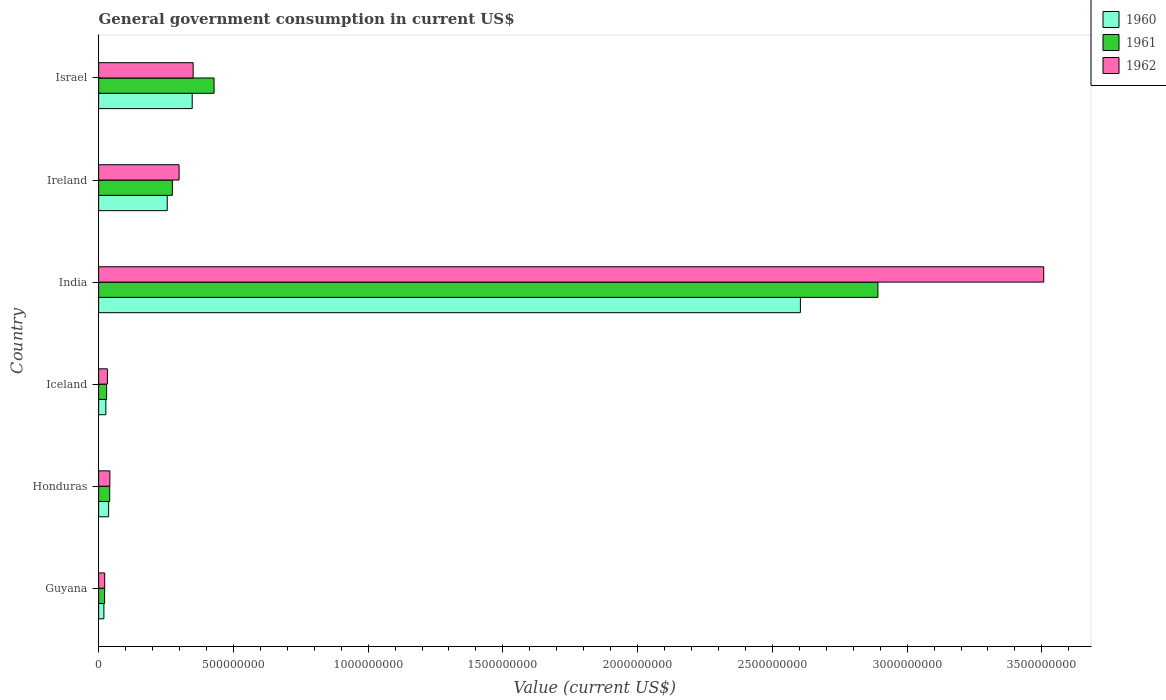How many groups of bars are there?
Offer a very short reply. 6. How many bars are there on the 6th tick from the bottom?
Make the answer very short. 3. What is the label of the 2nd group of bars from the top?
Keep it short and to the point. Ireland. What is the government conusmption in 1960 in Iceland?
Give a very brief answer. 2.68e+07. Across all countries, what is the maximum government conusmption in 1961?
Offer a very short reply. 2.89e+09. Across all countries, what is the minimum government conusmption in 1960?
Keep it short and to the point. 1.95e+07. In which country was the government conusmption in 1960 minimum?
Provide a succinct answer. Guyana. What is the total government conusmption in 1960 in the graph?
Give a very brief answer. 3.29e+09. What is the difference between the government conusmption in 1960 in Ireland and that in Israel?
Give a very brief answer. -9.27e+07. What is the difference between the government conusmption in 1960 in India and the government conusmption in 1962 in Ireland?
Make the answer very short. 2.31e+09. What is the average government conusmption in 1962 per country?
Offer a terse response. 7.09e+08. What is the difference between the government conusmption in 1960 and government conusmption in 1962 in Honduras?
Offer a very short reply. -4.50e+06. What is the ratio of the government conusmption in 1960 in Iceland to that in India?
Ensure brevity in your answer.  0.01. Is the difference between the government conusmption in 1960 in Honduras and Iceland greater than the difference between the government conusmption in 1962 in Honduras and Iceland?
Offer a very short reply. Yes. What is the difference between the highest and the second highest government conusmption in 1961?
Give a very brief answer. 2.46e+09. What is the difference between the highest and the lowest government conusmption in 1960?
Ensure brevity in your answer.  2.58e+09. What does the 2nd bar from the top in Iceland represents?
Offer a terse response. 1961. What does the 2nd bar from the bottom in Iceland represents?
Your answer should be very brief. 1961. Is it the case that in every country, the sum of the government conusmption in 1962 and government conusmption in 1961 is greater than the government conusmption in 1960?
Your answer should be very brief. Yes. Are all the bars in the graph horizontal?
Ensure brevity in your answer.  Yes. How many countries are there in the graph?
Your answer should be compact. 6. What is the difference between two consecutive major ticks on the X-axis?
Your answer should be compact. 5.00e+08. Are the values on the major ticks of X-axis written in scientific E-notation?
Offer a very short reply. No. Does the graph contain any zero values?
Give a very brief answer. No. Does the graph contain grids?
Make the answer very short. No. Where does the legend appear in the graph?
Offer a very short reply. Top right. How are the legend labels stacked?
Your answer should be compact. Vertical. What is the title of the graph?
Provide a short and direct response. General government consumption in current US$. What is the label or title of the X-axis?
Keep it short and to the point. Value (current US$). What is the label or title of the Y-axis?
Offer a terse response. Country. What is the Value (current US$) in 1960 in Guyana?
Your answer should be compact. 1.95e+07. What is the Value (current US$) in 1961 in Guyana?
Make the answer very short. 2.22e+07. What is the Value (current US$) of 1962 in Guyana?
Offer a very short reply. 2.25e+07. What is the Value (current US$) in 1960 in Honduras?
Your response must be concise. 3.72e+07. What is the Value (current US$) of 1961 in Honduras?
Your answer should be very brief. 4.10e+07. What is the Value (current US$) of 1962 in Honduras?
Provide a short and direct response. 4.16e+07. What is the Value (current US$) of 1960 in Iceland?
Your answer should be very brief. 2.68e+07. What is the Value (current US$) of 1961 in Iceland?
Your answer should be very brief. 2.95e+07. What is the Value (current US$) in 1962 in Iceland?
Give a very brief answer. 3.25e+07. What is the Value (current US$) in 1960 in India?
Your answer should be compact. 2.60e+09. What is the Value (current US$) in 1961 in India?
Provide a succinct answer. 2.89e+09. What is the Value (current US$) of 1962 in India?
Provide a short and direct response. 3.51e+09. What is the Value (current US$) in 1960 in Ireland?
Ensure brevity in your answer.  2.55e+08. What is the Value (current US$) in 1961 in Ireland?
Your response must be concise. 2.74e+08. What is the Value (current US$) of 1962 in Ireland?
Make the answer very short. 2.99e+08. What is the Value (current US$) in 1960 in Israel?
Your answer should be compact. 3.47e+08. What is the Value (current US$) of 1961 in Israel?
Ensure brevity in your answer.  4.28e+08. What is the Value (current US$) of 1962 in Israel?
Your response must be concise. 3.51e+08. Across all countries, what is the maximum Value (current US$) of 1960?
Your response must be concise. 2.60e+09. Across all countries, what is the maximum Value (current US$) in 1961?
Ensure brevity in your answer.  2.89e+09. Across all countries, what is the maximum Value (current US$) in 1962?
Your answer should be very brief. 3.51e+09. Across all countries, what is the minimum Value (current US$) in 1960?
Provide a short and direct response. 1.95e+07. Across all countries, what is the minimum Value (current US$) of 1961?
Ensure brevity in your answer.  2.22e+07. Across all countries, what is the minimum Value (current US$) in 1962?
Provide a short and direct response. 2.25e+07. What is the total Value (current US$) in 1960 in the graph?
Ensure brevity in your answer.  3.29e+09. What is the total Value (current US$) in 1961 in the graph?
Provide a succinct answer. 3.69e+09. What is the total Value (current US$) in 1962 in the graph?
Offer a very short reply. 4.25e+09. What is the difference between the Value (current US$) in 1960 in Guyana and that in Honduras?
Ensure brevity in your answer.  -1.77e+07. What is the difference between the Value (current US$) in 1961 in Guyana and that in Honduras?
Make the answer very short. -1.89e+07. What is the difference between the Value (current US$) of 1962 in Guyana and that in Honduras?
Your response must be concise. -1.91e+07. What is the difference between the Value (current US$) of 1960 in Guyana and that in Iceland?
Ensure brevity in your answer.  -7.28e+06. What is the difference between the Value (current US$) of 1961 in Guyana and that in Iceland?
Give a very brief answer. -7.36e+06. What is the difference between the Value (current US$) in 1962 in Guyana and that in Iceland?
Your answer should be very brief. -1.00e+07. What is the difference between the Value (current US$) of 1960 in Guyana and that in India?
Your response must be concise. -2.58e+09. What is the difference between the Value (current US$) in 1961 in Guyana and that in India?
Your response must be concise. -2.87e+09. What is the difference between the Value (current US$) of 1962 in Guyana and that in India?
Keep it short and to the point. -3.48e+09. What is the difference between the Value (current US$) of 1960 in Guyana and that in Ireland?
Give a very brief answer. -2.35e+08. What is the difference between the Value (current US$) in 1961 in Guyana and that in Ireland?
Offer a terse response. -2.51e+08. What is the difference between the Value (current US$) of 1962 in Guyana and that in Ireland?
Your response must be concise. -2.76e+08. What is the difference between the Value (current US$) in 1960 in Guyana and that in Israel?
Ensure brevity in your answer.  -3.28e+08. What is the difference between the Value (current US$) of 1961 in Guyana and that in Israel?
Keep it short and to the point. -4.06e+08. What is the difference between the Value (current US$) in 1962 in Guyana and that in Israel?
Make the answer very short. -3.28e+08. What is the difference between the Value (current US$) in 1960 in Honduras and that in Iceland?
Make the answer very short. 1.04e+07. What is the difference between the Value (current US$) of 1961 in Honduras and that in Iceland?
Ensure brevity in your answer.  1.15e+07. What is the difference between the Value (current US$) of 1962 in Honduras and that in Iceland?
Provide a succinct answer. 9.12e+06. What is the difference between the Value (current US$) in 1960 in Honduras and that in India?
Give a very brief answer. -2.57e+09. What is the difference between the Value (current US$) in 1961 in Honduras and that in India?
Offer a very short reply. -2.85e+09. What is the difference between the Value (current US$) of 1962 in Honduras and that in India?
Give a very brief answer. -3.47e+09. What is the difference between the Value (current US$) of 1960 in Honduras and that in Ireland?
Give a very brief answer. -2.17e+08. What is the difference between the Value (current US$) of 1961 in Honduras and that in Ireland?
Offer a very short reply. -2.33e+08. What is the difference between the Value (current US$) in 1962 in Honduras and that in Ireland?
Your response must be concise. -2.57e+08. What is the difference between the Value (current US$) of 1960 in Honduras and that in Israel?
Provide a short and direct response. -3.10e+08. What is the difference between the Value (current US$) of 1961 in Honduras and that in Israel?
Provide a short and direct response. -3.87e+08. What is the difference between the Value (current US$) of 1962 in Honduras and that in Israel?
Ensure brevity in your answer.  -3.09e+08. What is the difference between the Value (current US$) of 1960 in Iceland and that in India?
Your answer should be compact. -2.58e+09. What is the difference between the Value (current US$) in 1961 in Iceland and that in India?
Provide a short and direct response. -2.86e+09. What is the difference between the Value (current US$) in 1962 in Iceland and that in India?
Ensure brevity in your answer.  -3.47e+09. What is the difference between the Value (current US$) in 1960 in Iceland and that in Ireland?
Provide a succinct answer. -2.28e+08. What is the difference between the Value (current US$) of 1961 in Iceland and that in Ireland?
Offer a very short reply. -2.44e+08. What is the difference between the Value (current US$) of 1962 in Iceland and that in Ireland?
Ensure brevity in your answer.  -2.66e+08. What is the difference between the Value (current US$) of 1960 in Iceland and that in Israel?
Provide a short and direct response. -3.20e+08. What is the difference between the Value (current US$) in 1961 in Iceland and that in Israel?
Offer a very short reply. -3.99e+08. What is the difference between the Value (current US$) of 1962 in Iceland and that in Israel?
Your answer should be compact. -3.18e+08. What is the difference between the Value (current US$) in 1960 in India and that in Ireland?
Give a very brief answer. 2.35e+09. What is the difference between the Value (current US$) in 1961 in India and that in Ireland?
Ensure brevity in your answer.  2.62e+09. What is the difference between the Value (current US$) in 1962 in India and that in Ireland?
Your response must be concise. 3.21e+09. What is the difference between the Value (current US$) of 1960 in India and that in Israel?
Provide a short and direct response. 2.26e+09. What is the difference between the Value (current US$) in 1961 in India and that in Israel?
Provide a short and direct response. 2.46e+09. What is the difference between the Value (current US$) of 1962 in India and that in Israel?
Provide a succinct answer. 3.16e+09. What is the difference between the Value (current US$) in 1960 in Ireland and that in Israel?
Your answer should be very brief. -9.27e+07. What is the difference between the Value (current US$) in 1961 in Ireland and that in Israel?
Offer a terse response. -1.55e+08. What is the difference between the Value (current US$) of 1962 in Ireland and that in Israel?
Make the answer very short. -5.21e+07. What is the difference between the Value (current US$) in 1960 in Guyana and the Value (current US$) in 1961 in Honduras?
Provide a short and direct response. -2.16e+07. What is the difference between the Value (current US$) in 1960 in Guyana and the Value (current US$) in 1962 in Honduras?
Give a very brief answer. -2.22e+07. What is the difference between the Value (current US$) of 1961 in Guyana and the Value (current US$) of 1962 in Honduras?
Keep it short and to the point. -1.95e+07. What is the difference between the Value (current US$) of 1960 in Guyana and the Value (current US$) of 1961 in Iceland?
Provide a short and direct response. -1.00e+07. What is the difference between the Value (current US$) in 1960 in Guyana and the Value (current US$) in 1962 in Iceland?
Provide a succinct answer. -1.30e+07. What is the difference between the Value (current US$) of 1961 in Guyana and the Value (current US$) of 1962 in Iceland?
Your answer should be very brief. -1.04e+07. What is the difference between the Value (current US$) in 1960 in Guyana and the Value (current US$) in 1961 in India?
Ensure brevity in your answer.  -2.87e+09. What is the difference between the Value (current US$) in 1960 in Guyana and the Value (current US$) in 1962 in India?
Ensure brevity in your answer.  -3.49e+09. What is the difference between the Value (current US$) in 1961 in Guyana and the Value (current US$) in 1962 in India?
Your answer should be very brief. -3.48e+09. What is the difference between the Value (current US$) of 1960 in Guyana and the Value (current US$) of 1961 in Ireland?
Provide a short and direct response. -2.54e+08. What is the difference between the Value (current US$) in 1960 in Guyana and the Value (current US$) in 1962 in Ireland?
Ensure brevity in your answer.  -2.79e+08. What is the difference between the Value (current US$) of 1961 in Guyana and the Value (current US$) of 1962 in Ireland?
Offer a very short reply. -2.76e+08. What is the difference between the Value (current US$) of 1960 in Guyana and the Value (current US$) of 1961 in Israel?
Your response must be concise. -4.09e+08. What is the difference between the Value (current US$) of 1960 in Guyana and the Value (current US$) of 1962 in Israel?
Your answer should be compact. -3.31e+08. What is the difference between the Value (current US$) of 1961 in Guyana and the Value (current US$) of 1962 in Israel?
Ensure brevity in your answer.  -3.29e+08. What is the difference between the Value (current US$) of 1960 in Honduras and the Value (current US$) of 1961 in Iceland?
Your answer should be compact. 7.62e+06. What is the difference between the Value (current US$) in 1960 in Honduras and the Value (current US$) in 1962 in Iceland?
Make the answer very short. 4.62e+06. What is the difference between the Value (current US$) in 1961 in Honduras and the Value (current US$) in 1962 in Iceland?
Your response must be concise. 8.52e+06. What is the difference between the Value (current US$) in 1960 in Honduras and the Value (current US$) in 1961 in India?
Keep it short and to the point. -2.85e+09. What is the difference between the Value (current US$) of 1960 in Honduras and the Value (current US$) of 1962 in India?
Keep it short and to the point. -3.47e+09. What is the difference between the Value (current US$) of 1961 in Honduras and the Value (current US$) of 1962 in India?
Ensure brevity in your answer.  -3.47e+09. What is the difference between the Value (current US$) in 1960 in Honduras and the Value (current US$) in 1961 in Ireland?
Give a very brief answer. -2.37e+08. What is the difference between the Value (current US$) in 1960 in Honduras and the Value (current US$) in 1962 in Ireland?
Your answer should be compact. -2.61e+08. What is the difference between the Value (current US$) in 1961 in Honduras and the Value (current US$) in 1962 in Ireland?
Your answer should be compact. -2.58e+08. What is the difference between the Value (current US$) of 1960 in Honduras and the Value (current US$) of 1961 in Israel?
Make the answer very short. -3.91e+08. What is the difference between the Value (current US$) in 1960 in Honduras and the Value (current US$) in 1962 in Israel?
Your answer should be compact. -3.14e+08. What is the difference between the Value (current US$) in 1961 in Honduras and the Value (current US$) in 1962 in Israel?
Give a very brief answer. -3.10e+08. What is the difference between the Value (current US$) in 1960 in Iceland and the Value (current US$) in 1961 in India?
Your answer should be compact. -2.86e+09. What is the difference between the Value (current US$) in 1960 in Iceland and the Value (current US$) in 1962 in India?
Provide a short and direct response. -3.48e+09. What is the difference between the Value (current US$) of 1961 in Iceland and the Value (current US$) of 1962 in India?
Your response must be concise. -3.48e+09. What is the difference between the Value (current US$) of 1960 in Iceland and the Value (current US$) of 1961 in Ireland?
Provide a succinct answer. -2.47e+08. What is the difference between the Value (current US$) in 1960 in Iceland and the Value (current US$) in 1962 in Ireland?
Provide a short and direct response. -2.72e+08. What is the difference between the Value (current US$) of 1961 in Iceland and the Value (current US$) of 1962 in Ireland?
Offer a very short reply. -2.69e+08. What is the difference between the Value (current US$) in 1960 in Iceland and the Value (current US$) in 1961 in Israel?
Make the answer very short. -4.02e+08. What is the difference between the Value (current US$) of 1960 in Iceland and the Value (current US$) of 1962 in Israel?
Offer a terse response. -3.24e+08. What is the difference between the Value (current US$) of 1961 in Iceland and the Value (current US$) of 1962 in Israel?
Give a very brief answer. -3.21e+08. What is the difference between the Value (current US$) in 1960 in India and the Value (current US$) in 1961 in Ireland?
Ensure brevity in your answer.  2.33e+09. What is the difference between the Value (current US$) of 1960 in India and the Value (current US$) of 1962 in Ireland?
Ensure brevity in your answer.  2.31e+09. What is the difference between the Value (current US$) in 1961 in India and the Value (current US$) in 1962 in Ireland?
Your response must be concise. 2.59e+09. What is the difference between the Value (current US$) of 1960 in India and the Value (current US$) of 1961 in Israel?
Ensure brevity in your answer.  2.18e+09. What is the difference between the Value (current US$) of 1960 in India and the Value (current US$) of 1962 in Israel?
Make the answer very short. 2.25e+09. What is the difference between the Value (current US$) of 1961 in India and the Value (current US$) of 1962 in Israel?
Provide a short and direct response. 2.54e+09. What is the difference between the Value (current US$) of 1960 in Ireland and the Value (current US$) of 1961 in Israel?
Your answer should be very brief. -1.74e+08. What is the difference between the Value (current US$) of 1960 in Ireland and the Value (current US$) of 1962 in Israel?
Your response must be concise. -9.61e+07. What is the difference between the Value (current US$) of 1961 in Ireland and the Value (current US$) of 1962 in Israel?
Ensure brevity in your answer.  -7.70e+07. What is the average Value (current US$) in 1960 per country?
Your answer should be very brief. 5.48e+08. What is the average Value (current US$) of 1961 per country?
Provide a short and direct response. 6.14e+08. What is the average Value (current US$) in 1962 per country?
Keep it short and to the point. 7.09e+08. What is the difference between the Value (current US$) of 1960 and Value (current US$) of 1961 in Guyana?
Offer a very short reply. -2.68e+06. What is the difference between the Value (current US$) in 1960 and Value (current US$) in 1962 in Guyana?
Ensure brevity in your answer.  -3.03e+06. What is the difference between the Value (current US$) in 1961 and Value (current US$) in 1962 in Guyana?
Give a very brief answer. -3.50e+05. What is the difference between the Value (current US$) in 1960 and Value (current US$) in 1961 in Honduras?
Offer a very short reply. -3.90e+06. What is the difference between the Value (current US$) of 1960 and Value (current US$) of 1962 in Honduras?
Ensure brevity in your answer.  -4.50e+06. What is the difference between the Value (current US$) in 1961 and Value (current US$) in 1962 in Honduras?
Ensure brevity in your answer.  -6.00e+05. What is the difference between the Value (current US$) in 1960 and Value (current US$) in 1961 in Iceland?
Give a very brief answer. -2.77e+06. What is the difference between the Value (current US$) of 1960 and Value (current US$) of 1962 in Iceland?
Ensure brevity in your answer.  -5.77e+06. What is the difference between the Value (current US$) in 1961 and Value (current US$) in 1962 in Iceland?
Offer a terse response. -3.00e+06. What is the difference between the Value (current US$) in 1960 and Value (current US$) in 1961 in India?
Provide a short and direct response. -2.88e+08. What is the difference between the Value (current US$) of 1960 and Value (current US$) of 1962 in India?
Offer a terse response. -9.03e+08. What is the difference between the Value (current US$) in 1961 and Value (current US$) in 1962 in India?
Give a very brief answer. -6.15e+08. What is the difference between the Value (current US$) in 1960 and Value (current US$) in 1961 in Ireland?
Give a very brief answer. -1.91e+07. What is the difference between the Value (current US$) in 1960 and Value (current US$) in 1962 in Ireland?
Provide a succinct answer. -4.40e+07. What is the difference between the Value (current US$) in 1961 and Value (current US$) in 1962 in Ireland?
Offer a very short reply. -2.49e+07. What is the difference between the Value (current US$) of 1960 and Value (current US$) of 1961 in Israel?
Provide a short and direct response. -8.11e+07. What is the difference between the Value (current US$) in 1960 and Value (current US$) in 1962 in Israel?
Your response must be concise. -3.47e+06. What is the difference between the Value (current US$) of 1961 and Value (current US$) of 1962 in Israel?
Ensure brevity in your answer.  7.76e+07. What is the ratio of the Value (current US$) of 1960 in Guyana to that in Honduras?
Make the answer very short. 0.52. What is the ratio of the Value (current US$) of 1961 in Guyana to that in Honduras?
Offer a very short reply. 0.54. What is the ratio of the Value (current US$) of 1962 in Guyana to that in Honduras?
Provide a succinct answer. 0.54. What is the ratio of the Value (current US$) in 1960 in Guyana to that in Iceland?
Your response must be concise. 0.73. What is the ratio of the Value (current US$) in 1961 in Guyana to that in Iceland?
Your answer should be very brief. 0.75. What is the ratio of the Value (current US$) of 1962 in Guyana to that in Iceland?
Give a very brief answer. 0.69. What is the ratio of the Value (current US$) of 1960 in Guyana to that in India?
Offer a terse response. 0.01. What is the ratio of the Value (current US$) of 1961 in Guyana to that in India?
Provide a short and direct response. 0.01. What is the ratio of the Value (current US$) of 1962 in Guyana to that in India?
Your answer should be very brief. 0.01. What is the ratio of the Value (current US$) in 1960 in Guyana to that in Ireland?
Your response must be concise. 0.08. What is the ratio of the Value (current US$) of 1961 in Guyana to that in Ireland?
Give a very brief answer. 0.08. What is the ratio of the Value (current US$) in 1962 in Guyana to that in Ireland?
Offer a very short reply. 0.08. What is the ratio of the Value (current US$) of 1960 in Guyana to that in Israel?
Offer a very short reply. 0.06. What is the ratio of the Value (current US$) in 1961 in Guyana to that in Israel?
Ensure brevity in your answer.  0.05. What is the ratio of the Value (current US$) of 1962 in Guyana to that in Israel?
Your answer should be compact. 0.06. What is the ratio of the Value (current US$) in 1960 in Honduras to that in Iceland?
Provide a short and direct response. 1.39. What is the ratio of the Value (current US$) in 1961 in Honduras to that in Iceland?
Your answer should be compact. 1.39. What is the ratio of the Value (current US$) in 1962 in Honduras to that in Iceland?
Your response must be concise. 1.28. What is the ratio of the Value (current US$) of 1960 in Honduras to that in India?
Your response must be concise. 0.01. What is the ratio of the Value (current US$) in 1961 in Honduras to that in India?
Offer a very short reply. 0.01. What is the ratio of the Value (current US$) in 1962 in Honduras to that in India?
Your answer should be compact. 0.01. What is the ratio of the Value (current US$) in 1960 in Honduras to that in Ireland?
Give a very brief answer. 0.15. What is the ratio of the Value (current US$) of 1962 in Honduras to that in Ireland?
Provide a succinct answer. 0.14. What is the ratio of the Value (current US$) of 1960 in Honduras to that in Israel?
Offer a terse response. 0.11. What is the ratio of the Value (current US$) in 1961 in Honduras to that in Israel?
Keep it short and to the point. 0.1. What is the ratio of the Value (current US$) of 1962 in Honduras to that in Israel?
Give a very brief answer. 0.12. What is the ratio of the Value (current US$) of 1960 in Iceland to that in India?
Make the answer very short. 0.01. What is the ratio of the Value (current US$) in 1961 in Iceland to that in India?
Offer a very short reply. 0.01. What is the ratio of the Value (current US$) in 1962 in Iceland to that in India?
Provide a succinct answer. 0.01. What is the ratio of the Value (current US$) of 1960 in Iceland to that in Ireland?
Your response must be concise. 0.11. What is the ratio of the Value (current US$) in 1961 in Iceland to that in Ireland?
Offer a terse response. 0.11. What is the ratio of the Value (current US$) in 1962 in Iceland to that in Ireland?
Offer a terse response. 0.11. What is the ratio of the Value (current US$) in 1960 in Iceland to that in Israel?
Offer a terse response. 0.08. What is the ratio of the Value (current US$) in 1961 in Iceland to that in Israel?
Your response must be concise. 0.07. What is the ratio of the Value (current US$) of 1962 in Iceland to that in Israel?
Give a very brief answer. 0.09. What is the ratio of the Value (current US$) of 1960 in India to that in Ireland?
Your response must be concise. 10.23. What is the ratio of the Value (current US$) in 1961 in India to that in Ireland?
Provide a short and direct response. 10.57. What is the ratio of the Value (current US$) of 1962 in India to that in Ireland?
Keep it short and to the point. 11.75. What is the ratio of the Value (current US$) in 1960 in India to that in Israel?
Offer a very short reply. 7.5. What is the ratio of the Value (current US$) in 1961 in India to that in Israel?
Keep it short and to the point. 6.75. What is the ratio of the Value (current US$) of 1962 in India to that in Israel?
Provide a short and direct response. 10. What is the ratio of the Value (current US$) in 1960 in Ireland to that in Israel?
Ensure brevity in your answer.  0.73. What is the ratio of the Value (current US$) of 1961 in Ireland to that in Israel?
Offer a terse response. 0.64. What is the ratio of the Value (current US$) of 1962 in Ireland to that in Israel?
Provide a succinct answer. 0.85. What is the difference between the highest and the second highest Value (current US$) of 1960?
Make the answer very short. 2.26e+09. What is the difference between the highest and the second highest Value (current US$) of 1961?
Keep it short and to the point. 2.46e+09. What is the difference between the highest and the second highest Value (current US$) of 1962?
Provide a succinct answer. 3.16e+09. What is the difference between the highest and the lowest Value (current US$) of 1960?
Your answer should be very brief. 2.58e+09. What is the difference between the highest and the lowest Value (current US$) in 1961?
Your response must be concise. 2.87e+09. What is the difference between the highest and the lowest Value (current US$) in 1962?
Your answer should be compact. 3.48e+09. 